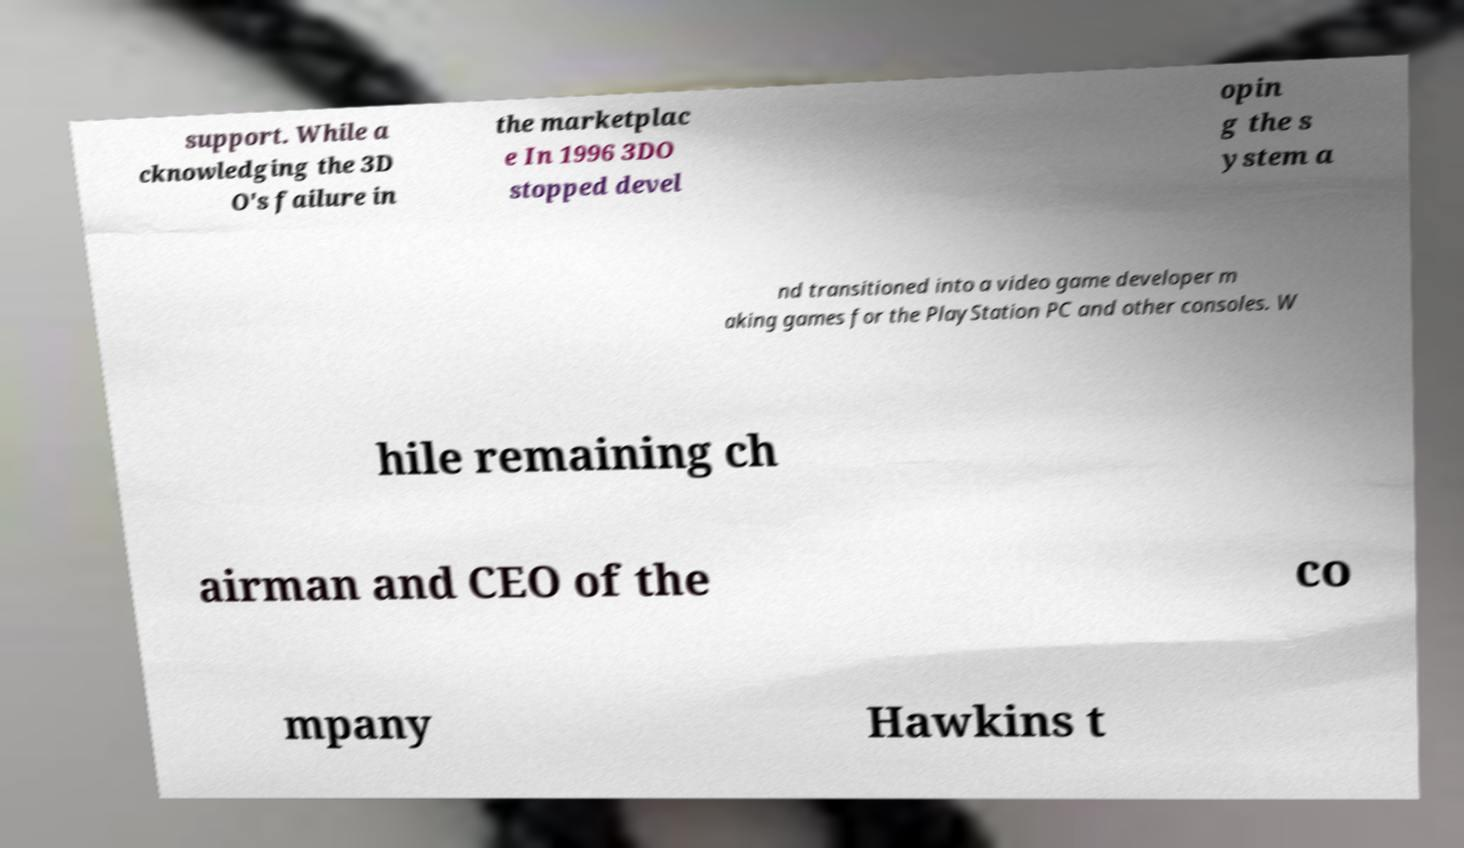What messages or text are displayed in this image? I need them in a readable, typed format. support. While a cknowledging the 3D O's failure in the marketplac e In 1996 3DO stopped devel opin g the s ystem a nd transitioned into a video game developer m aking games for the PlayStation PC and other consoles. W hile remaining ch airman and CEO of the co mpany Hawkins t 